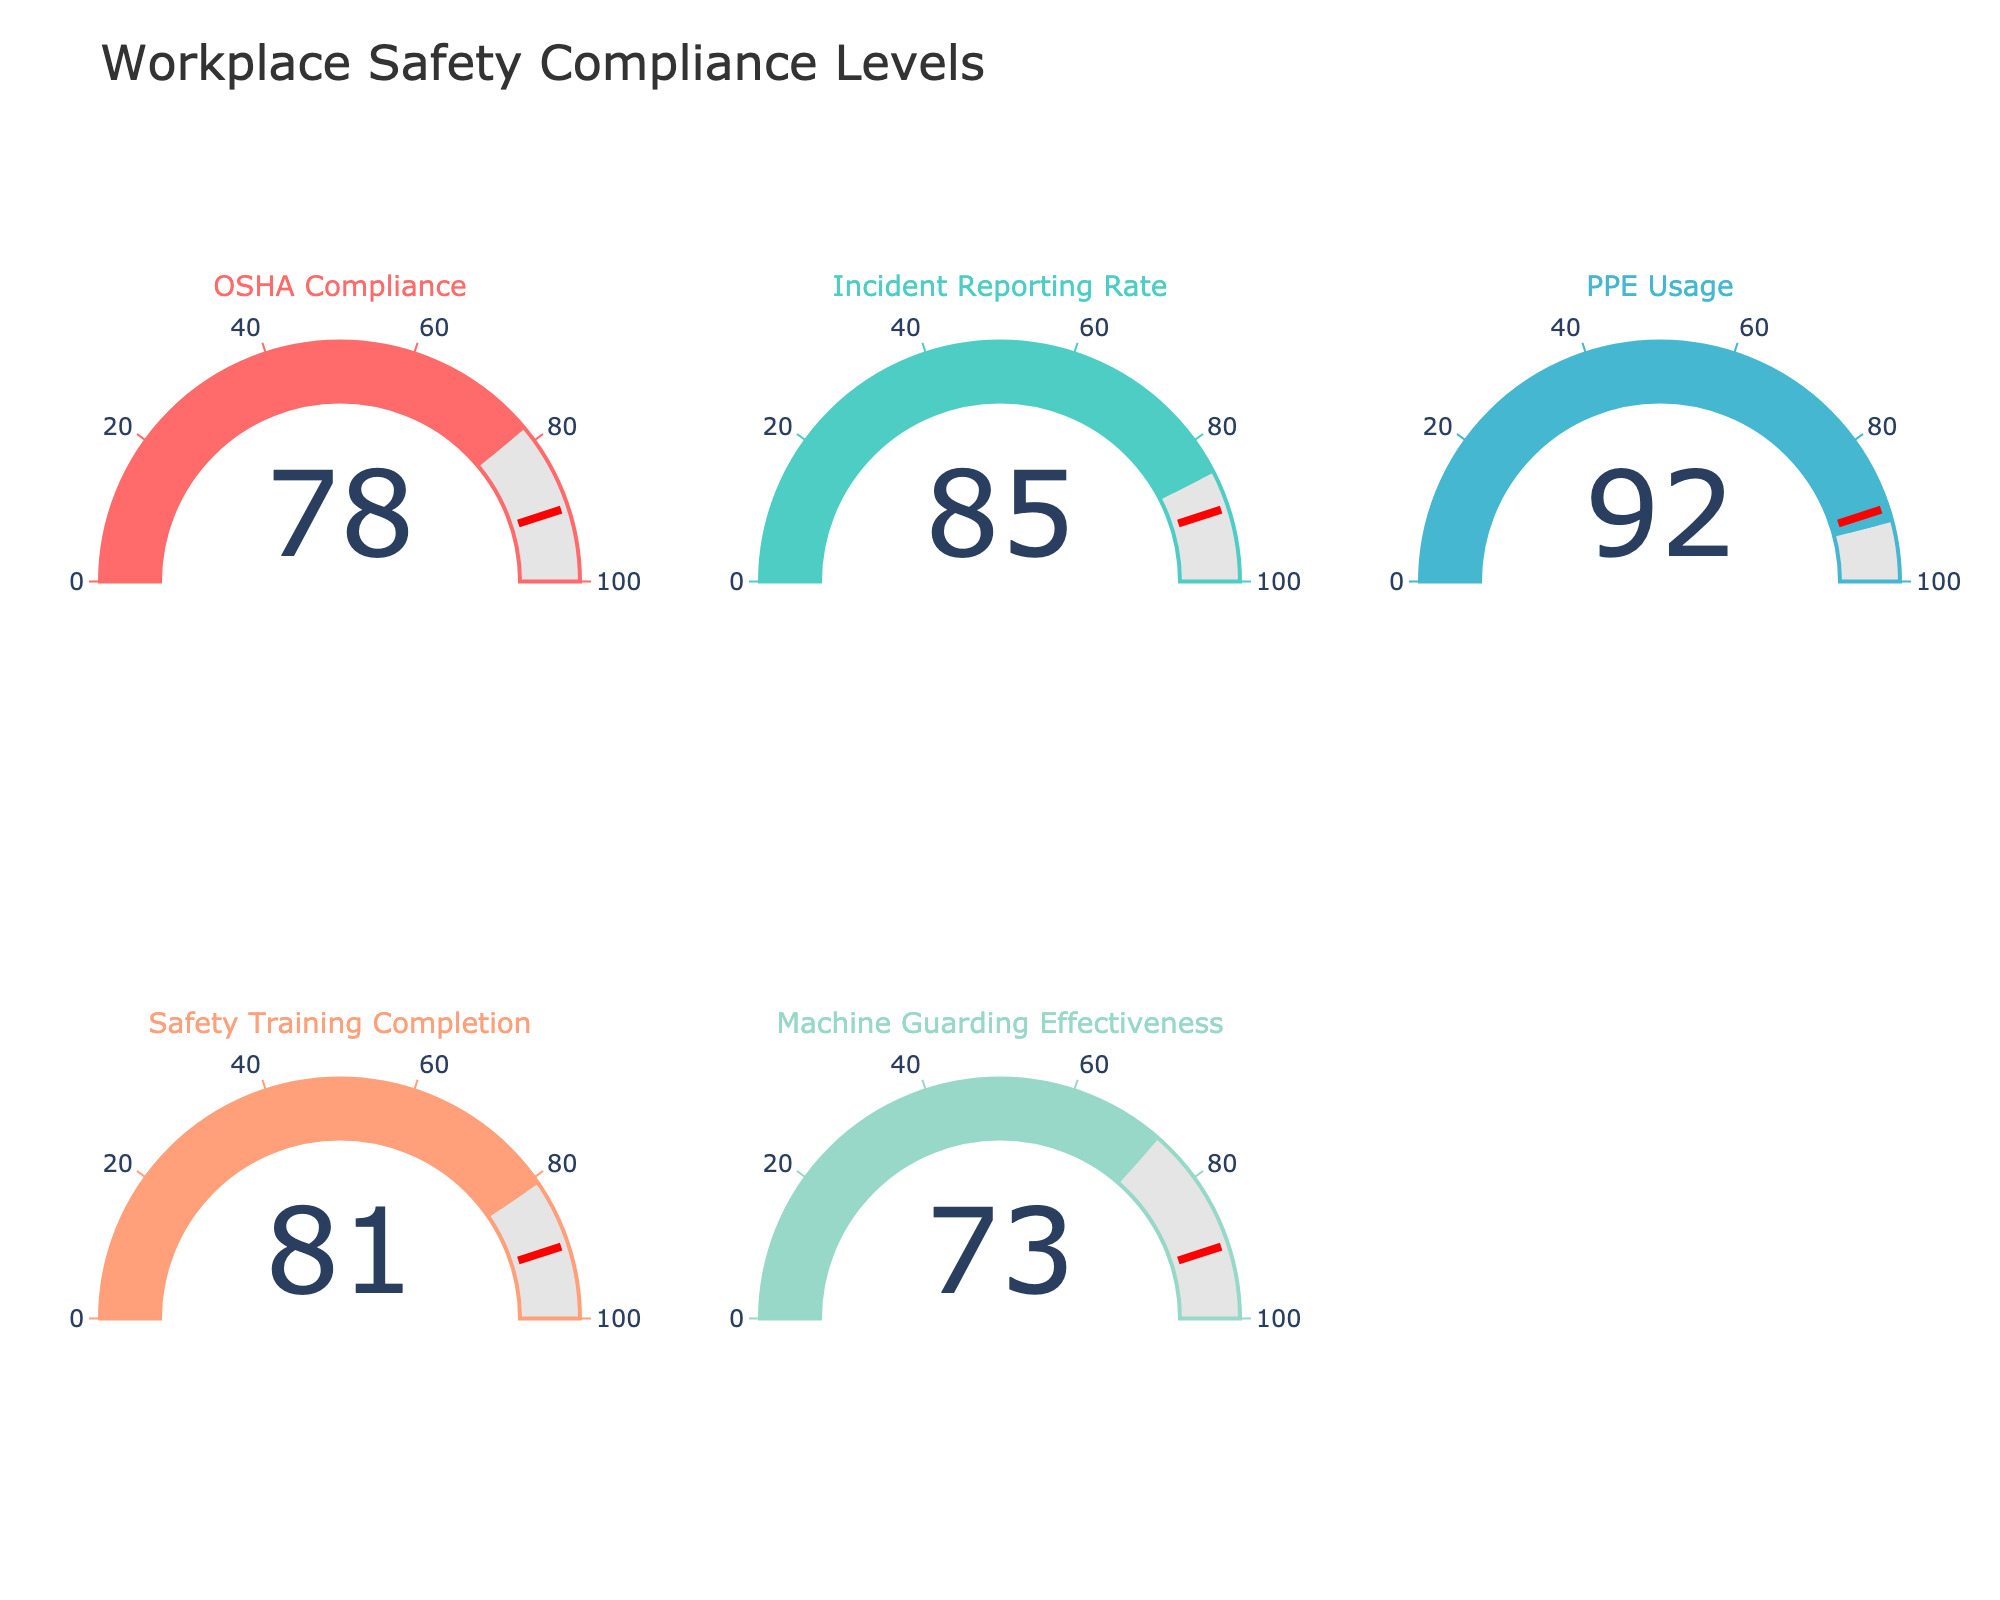Which category has the highest compliance value? To determine this, look at the gauges and find the category with the highest number (which is 92).
Answer: PPE Usage How many categories have compliance values above 80? Check each gauge and count the categories with values greater than 80. OSHA Compliance, Incident Reporting Rate, PPE Usage, and Safety Training Completion are above 80.
Answer: 4 What is the average compliance value across all categories? Add together the values of all categories (78 + 85 + 92 + 81 + 73 = 409) and then divide by the number of categories (5).
Answer: 81.8 Which category has the lowest compliance value? Check each gauge and find the category with the lowest number (which is 73).
Answer: Machine Guarding Effectiveness How much greater is the PPE Usage compliance than the Machine Guarding Effectiveness compliance? Subtract the value of Machine Guarding Effectiveness from the value of PPE Usage (92 - 73).
Answer: 19 Which category is closest to the threshold value of 90? Identify the compliance values and find the one nearest to 90, which is 85 (Incident Reporting Rate).
Answer: Incident Reporting Rate If the compliance threshold is set at 90, how many categories fail to meet this threshold? Compare each category's compliance value to 90 and count those that fall below it. OSHA Compliance, Incident Reporting Rate, Safety Training Completion, and Machine Guarding Effectiveness are all below 90.
Answer: 4 What is the median compliance value among the categories? Order the compliance values (73, 78, 81, 85, 92) and find the middle number.
Answer: 81 By how much does the Incident Reporting Rate exceed the OSHA Compliance level? Subtract the value of OSHA Compliance from the Incident Reporting Rate (85 - 78).
Answer: 7 